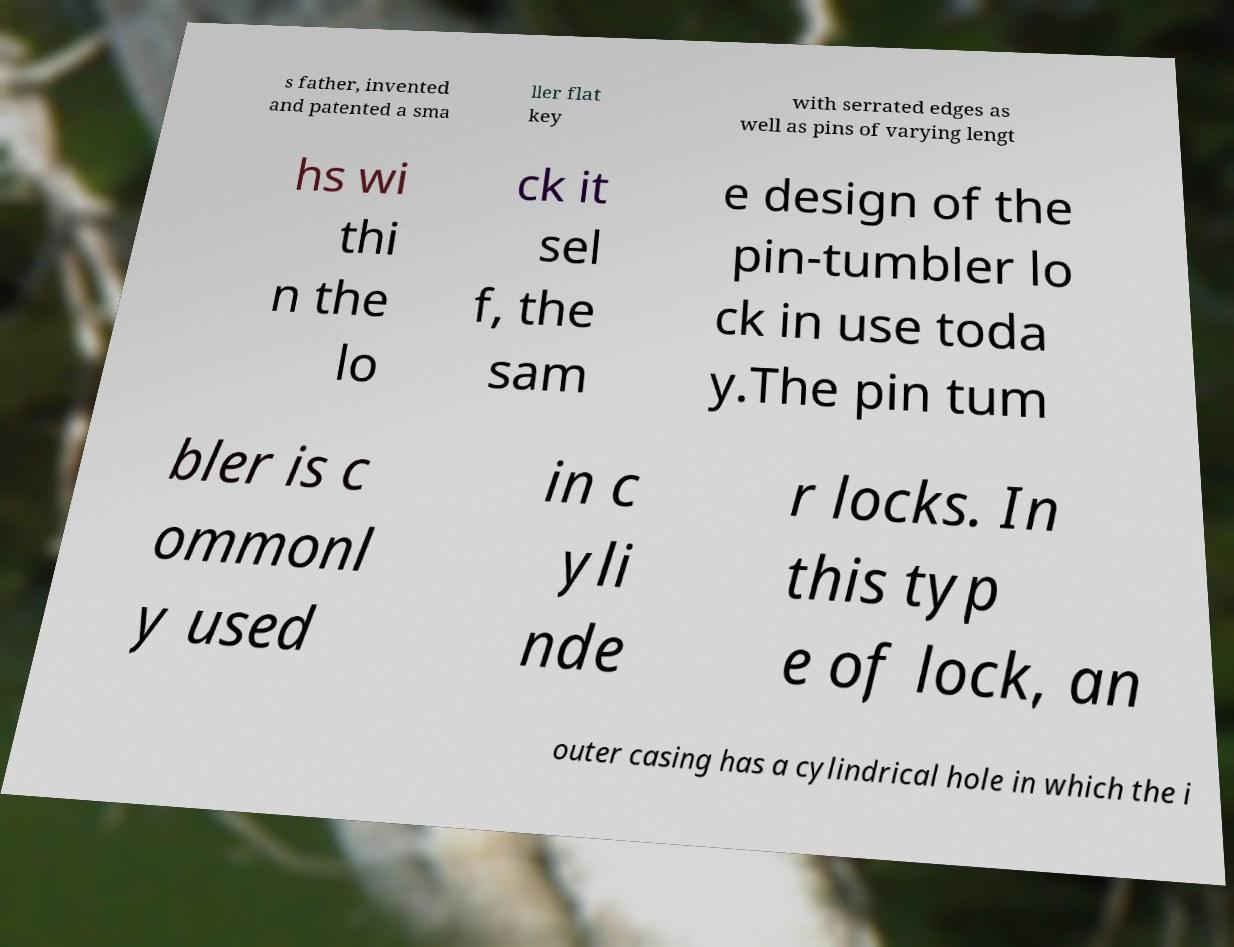Could you assist in decoding the text presented in this image and type it out clearly? s father, invented and patented a sma ller flat key with serrated edges as well as pins of varying lengt hs wi thi n the lo ck it sel f, the sam e design of the pin-tumbler lo ck in use toda y.The pin tum bler is c ommonl y used in c yli nde r locks. In this typ e of lock, an outer casing has a cylindrical hole in which the i 